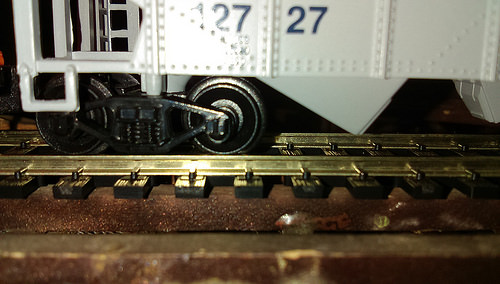<image>
Is the train on the tracks? Yes. Looking at the image, I can see the train is positioned on top of the tracks, with the tracks providing support. 